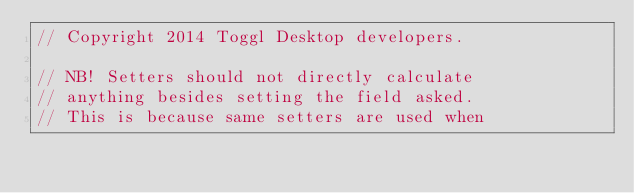<code> <loc_0><loc_0><loc_500><loc_500><_C++_>// Copyright 2014 Toggl Desktop developers.

// NB! Setters should not directly calculate
// anything besides setting the field asked.
// This is because same setters are used when</code> 